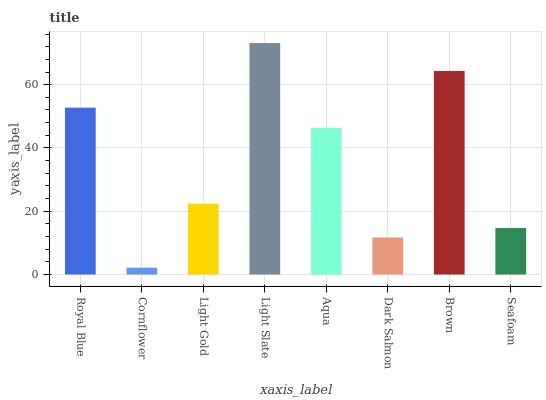Is Light Gold the minimum?
Answer yes or no. No. Is Light Gold the maximum?
Answer yes or no. No. Is Light Gold greater than Cornflower?
Answer yes or no. Yes. Is Cornflower less than Light Gold?
Answer yes or no. Yes. Is Cornflower greater than Light Gold?
Answer yes or no. No. Is Light Gold less than Cornflower?
Answer yes or no. No. Is Aqua the high median?
Answer yes or no. Yes. Is Light Gold the low median?
Answer yes or no. Yes. Is Cornflower the high median?
Answer yes or no. No. Is Brown the low median?
Answer yes or no. No. 